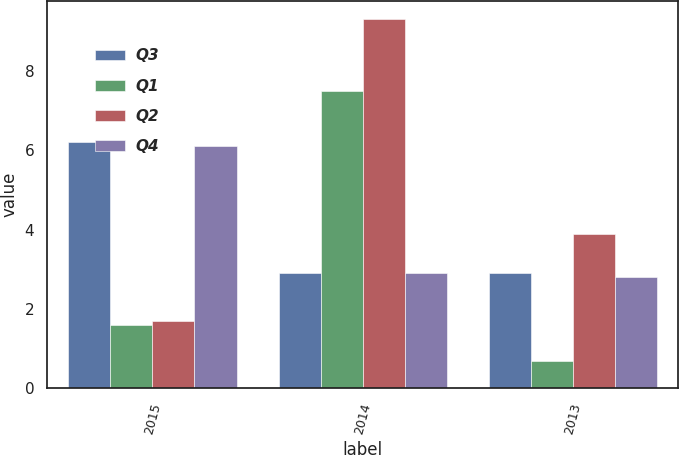<chart> <loc_0><loc_0><loc_500><loc_500><stacked_bar_chart><ecel><fcel>2015<fcel>2014<fcel>2013<nl><fcel>Q3<fcel>6.2<fcel>2.9<fcel>2.9<nl><fcel>Q1<fcel>1.6<fcel>7.5<fcel>0.7<nl><fcel>Q2<fcel>1.7<fcel>9.3<fcel>3.9<nl><fcel>Q4<fcel>6.1<fcel>2.9<fcel>2.8<nl></chart> 